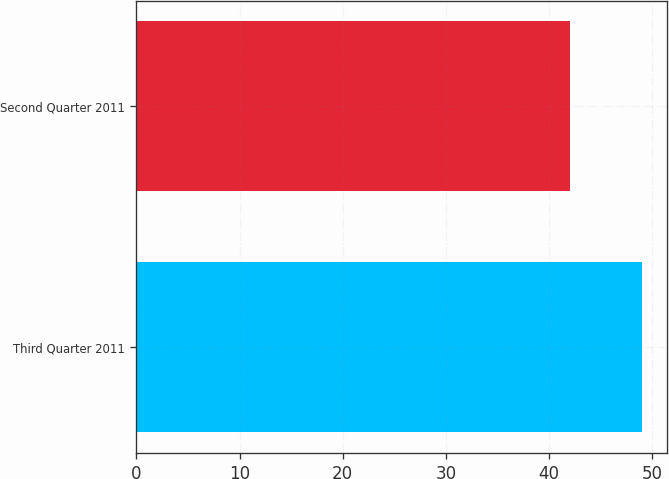Convert chart to OTSL. <chart><loc_0><loc_0><loc_500><loc_500><bar_chart><fcel>Third Quarter 2011<fcel>Second Quarter 2011<nl><fcel>49<fcel>42<nl></chart> 